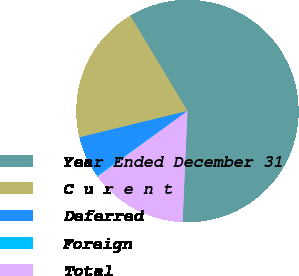Convert chart. <chart><loc_0><loc_0><loc_500><loc_500><pie_chart><fcel>Year Ended December 31<fcel>C u r e n t<fcel>Deferred<fcel>Foreign<fcel>Total<nl><fcel>59.3%<fcel>20.2%<fcel>6.06%<fcel>0.15%<fcel>14.29%<nl></chart> 